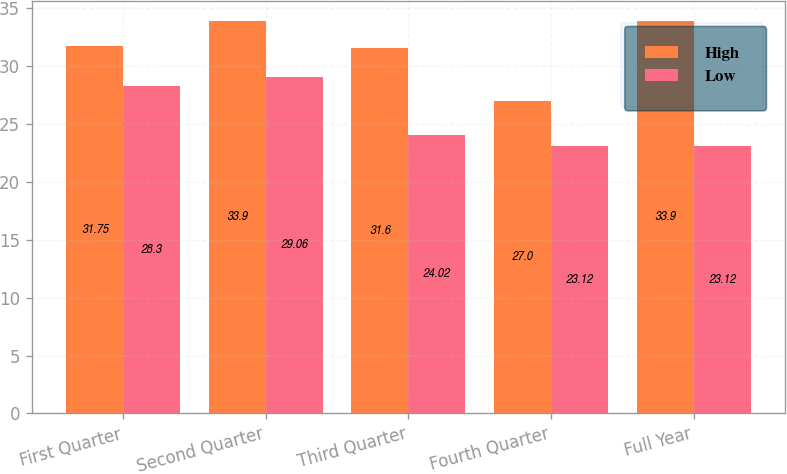Convert chart to OTSL. <chart><loc_0><loc_0><loc_500><loc_500><stacked_bar_chart><ecel><fcel>First Quarter<fcel>Second Quarter<fcel>Third Quarter<fcel>Fourth Quarter<fcel>Full Year<nl><fcel>High<fcel>31.75<fcel>33.9<fcel>31.6<fcel>27<fcel>33.9<nl><fcel>Low<fcel>28.3<fcel>29.06<fcel>24.02<fcel>23.12<fcel>23.12<nl></chart> 